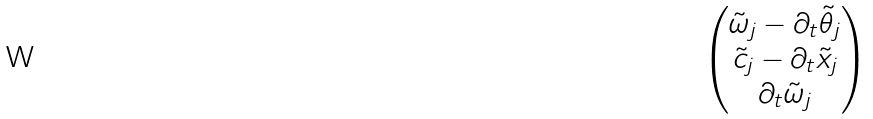Convert formula to latex. <formula><loc_0><loc_0><loc_500><loc_500>\begin{pmatrix} \tilde { \omega } _ { j } - \partial _ { t } \tilde { \theta } _ { j } \\ \tilde { c } _ { j } - \partial _ { t } \tilde { x } _ { j } \\ \partial _ { t } \tilde { \omega } _ { j } \end{pmatrix}</formula> 